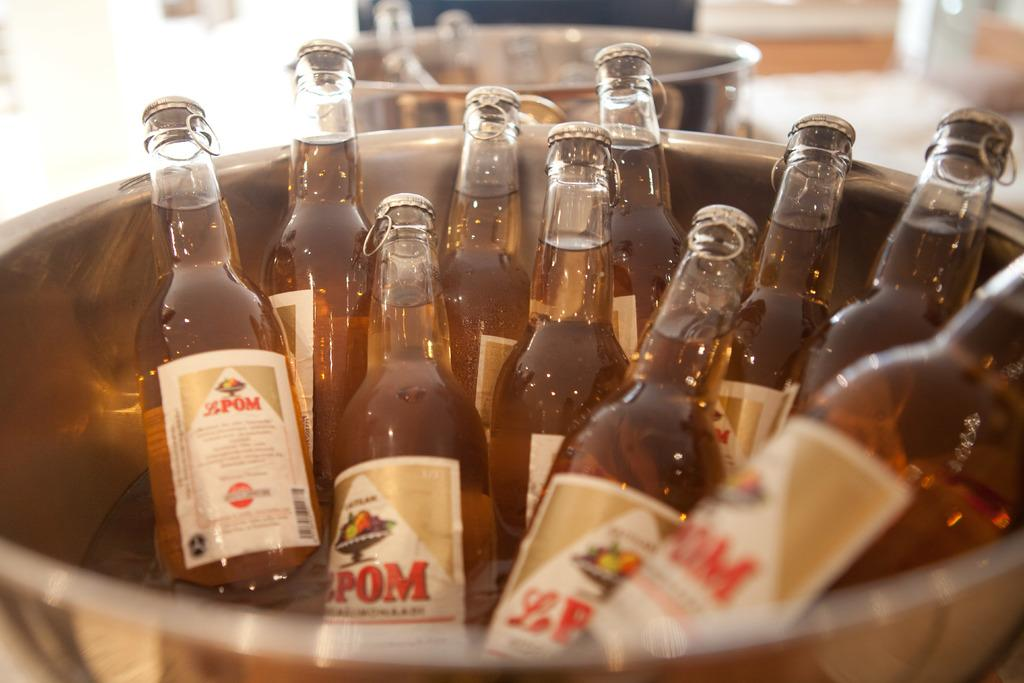What type of objects are in the image? There are glass bottles in the image. How are the glass bottles arranged or organized? The glass bottles are in a container. What type of berry is used to create the mask in the image? There is no berry or mask present in the image; it only features glass bottles in a container. 